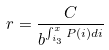Convert formula to latex. <formula><loc_0><loc_0><loc_500><loc_500>r = \frac { C } { b ^ { \int _ { i _ { 3 } } ^ { x } P ( i ) d i } }</formula> 